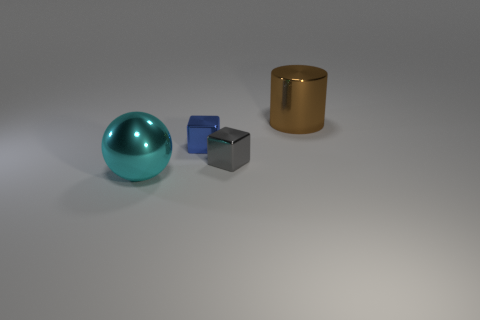What number of objects are either large cyan things or blocks?
Ensure brevity in your answer.  3. There is a sphere on the left side of the tiny blue cube; what size is it?
Give a very brief answer. Large. What is the color of the thing that is both in front of the blue metal object and right of the big cyan metal object?
Make the answer very short. Gray. Are there any big objects in front of the large brown object?
Your answer should be compact. Yes. There is a shiny cube that is behind the small gray shiny object; is it the same size as the metallic thing behind the tiny blue metal cube?
Your answer should be compact. No. Are there any things of the same size as the gray metallic cube?
Provide a succinct answer. Yes. There is a big metal thing behind the big cyan sphere; is its shape the same as the small blue object?
Provide a short and direct response. No. What material is the large object that is to the right of the small blue cube?
Your response must be concise. Metal. There is a large object that is left of the big object behind the sphere; what shape is it?
Give a very brief answer. Sphere. There is a small gray metal object; is it the same shape as the small thing that is behind the gray object?
Offer a terse response. Yes. 